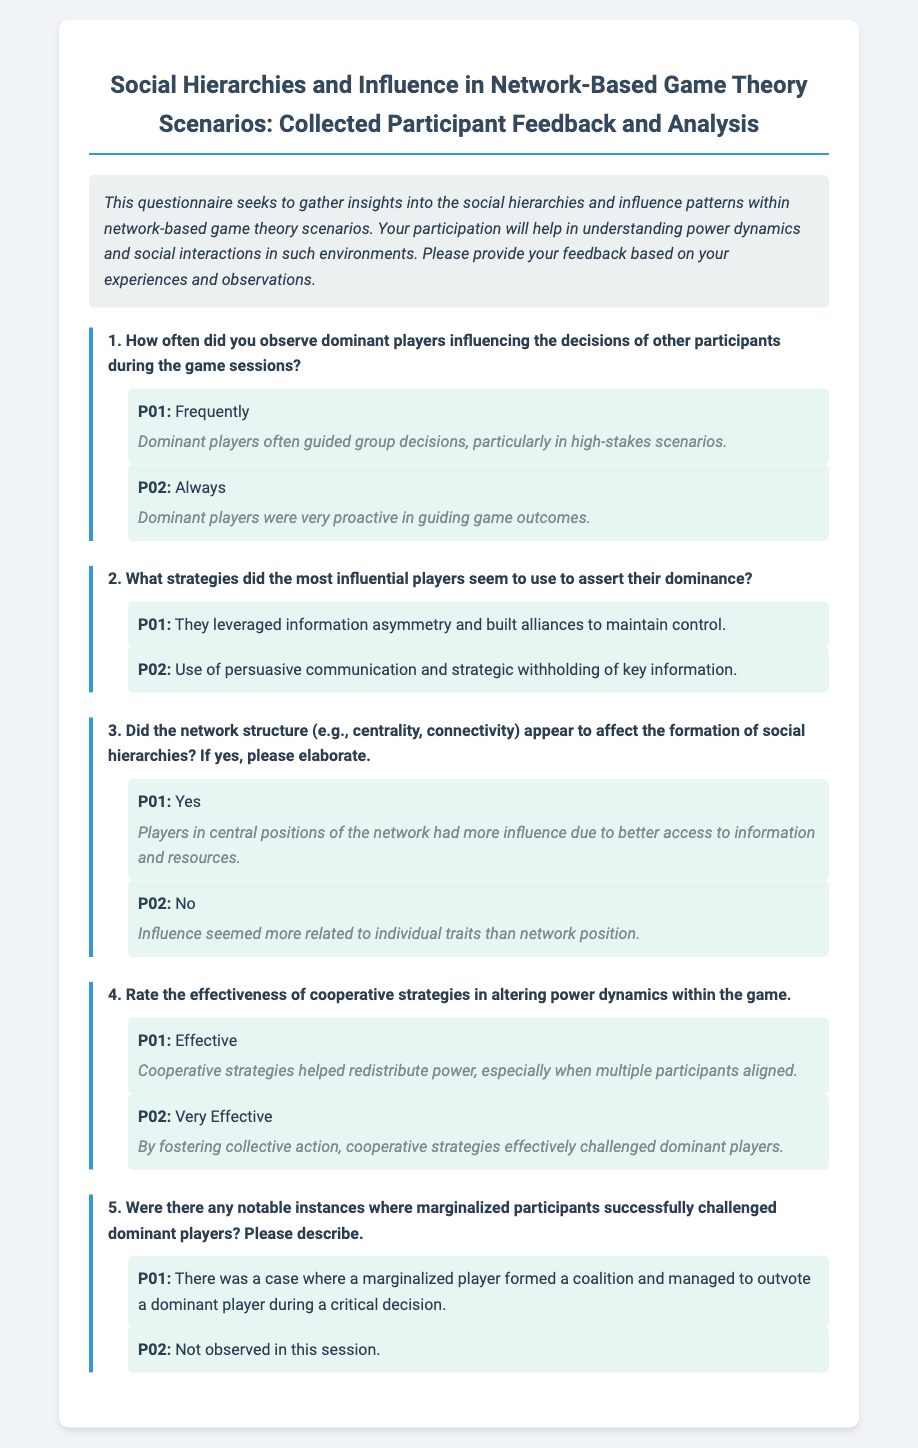What was the primary focus of the questionnaire? The questionnaire aimed to gather insights into social hierarchies and influence patterns in network-based game theory scenarios.
Answer: Social hierarchies and influence patterns How often did participant P02 observe dominant players influencing decisions? Participant P02 answered that they observed dominant players influencing decisions "Always."
Answer: Always What strategies did influential players use, according to participant P01? Participant P01 stated that influential players leveraged information asymmetry and built alliances.
Answer: Leveraged information asymmetry and built alliances Did P01 believe that the network structure affected social hierarchies? P01 responded "Yes" to whether the network structure affected social hierarchies and cited central positions as influential.
Answer: Yes On a scale of effectiveness, how did P02 rate cooperative strategies? P02 rated cooperative strategies as "Very Effective" in altering power dynamics within the game.
Answer: Very Effective 